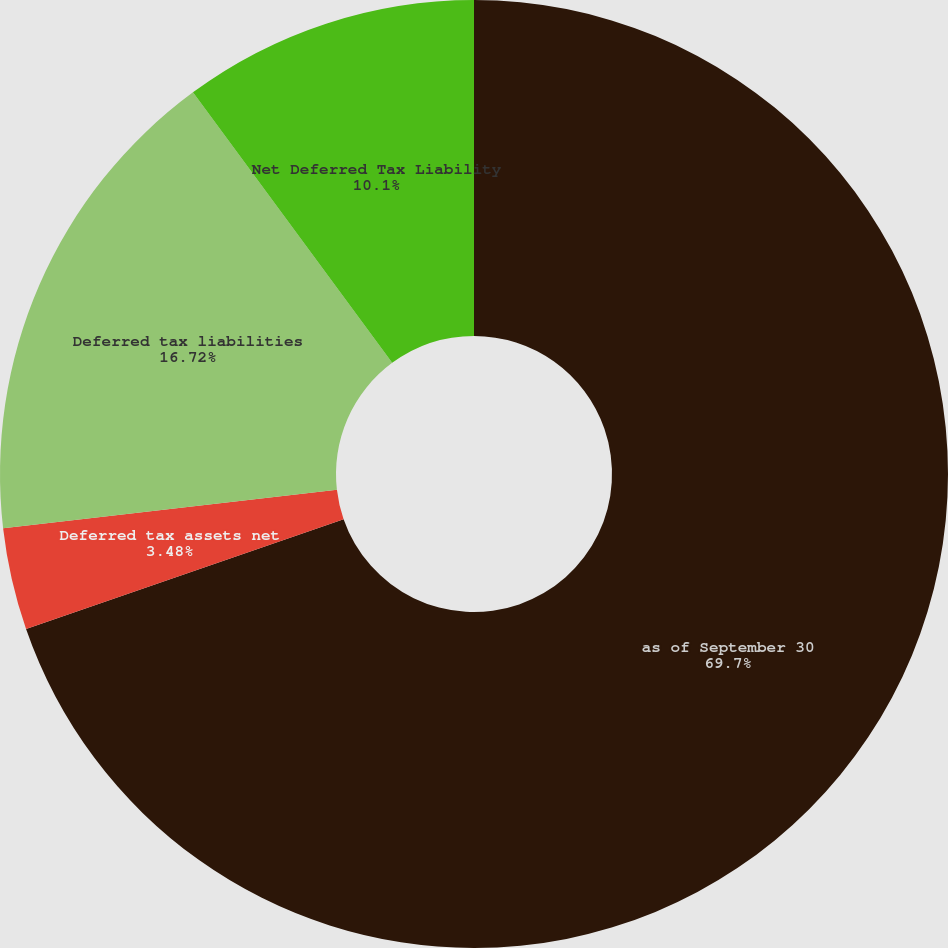Convert chart. <chart><loc_0><loc_0><loc_500><loc_500><pie_chart><fcel>as of September 30<fcel>Deferred tax assets net<fcel>Deferred tax liabilities<fcel>Net Deferred Tax Liability<nl><fcel>69.69%<fcel>3.48%<fcel>16.72%<fcel>10.1%<nl></chart> 